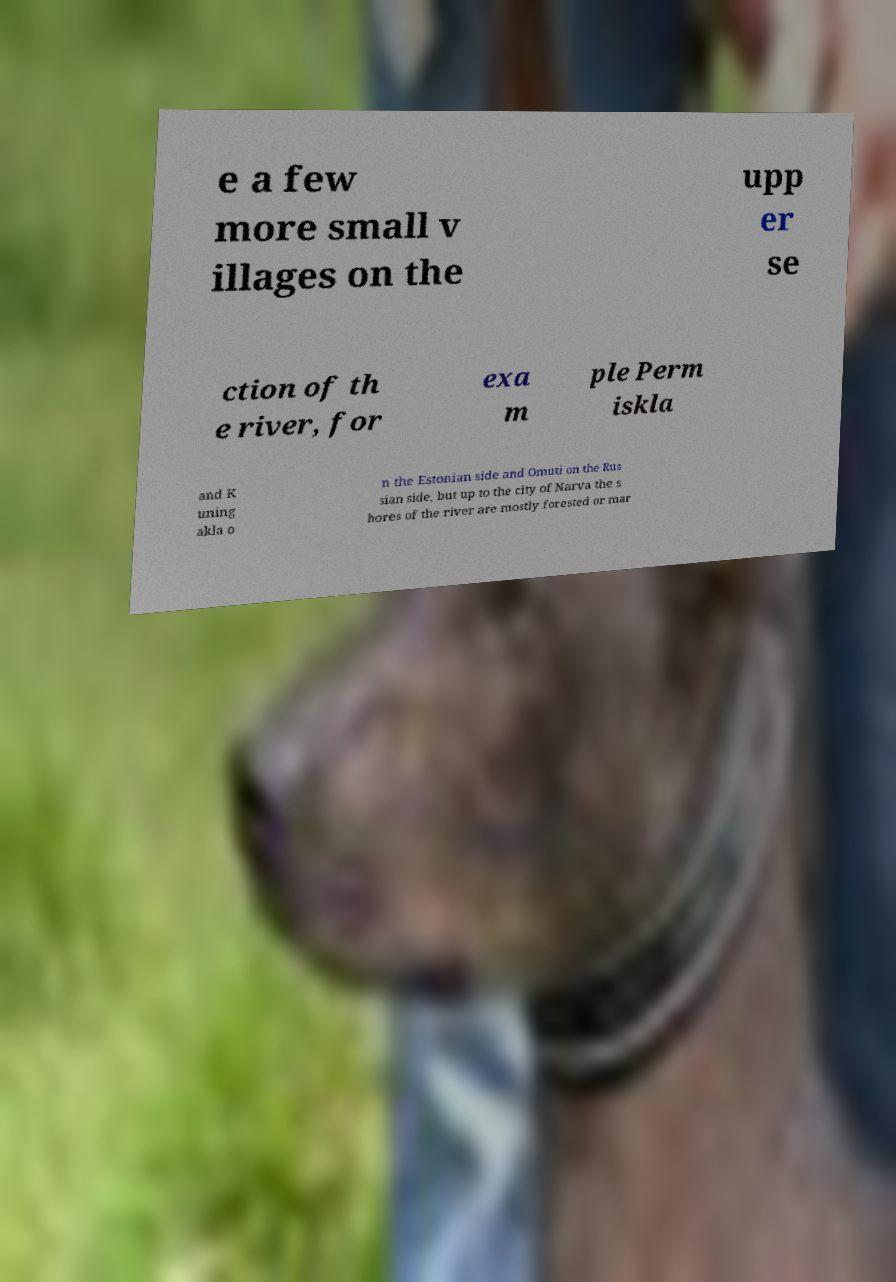What messages or text are displayed in this image? I need them in a readable, typed format. e a few more small v illages on the upp er se ction of th e river, for exa m ple Perm iskla and K uning akla o n the Estonian side and Omuti on the Rus sian side, but up to the city of Narva the s hores of the river are mostly forested or mar 